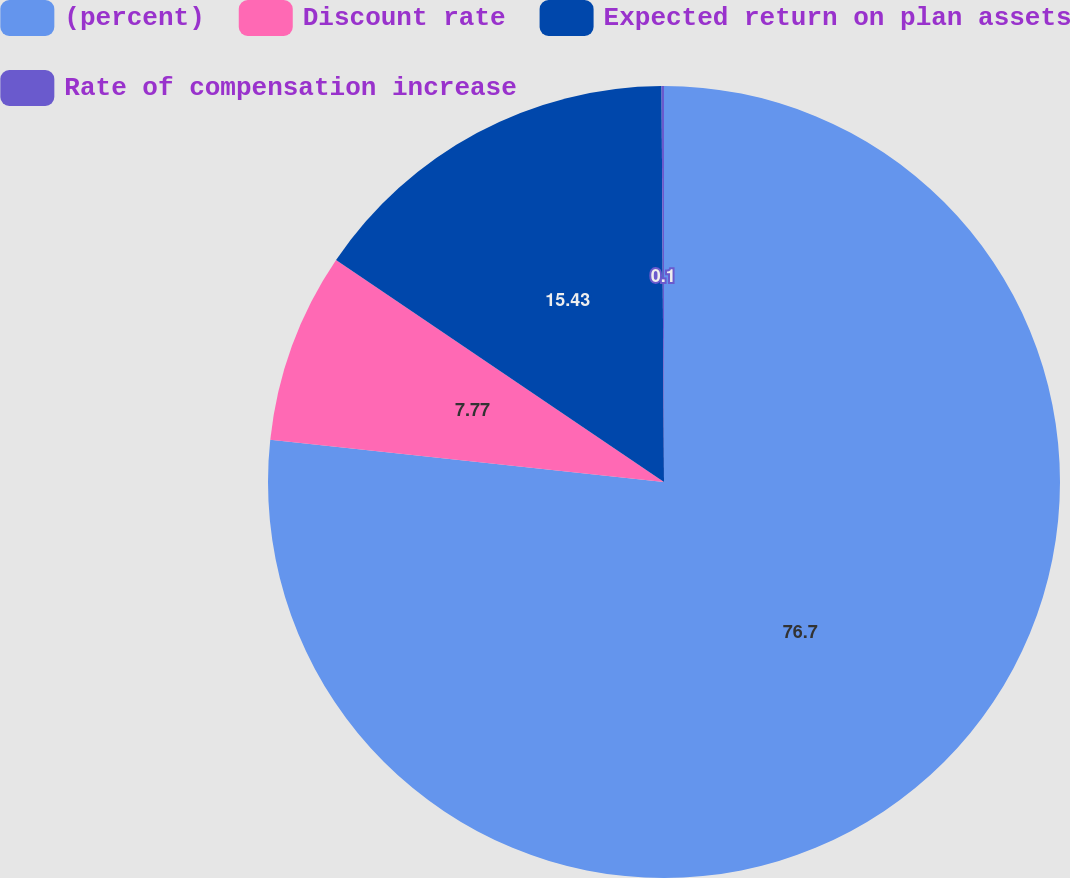<chart> <loc_0><loc_0><loc_500><loc_500><pie_chart><fcel>(percent)<fcel>Discount rate<fcel>Expected return on plan assets<fcel>Rate of compensation increase<nl><fcel>76.7%<fcel>7.77%<fcel>15.43%<fcel>0.1%<nl></chart> 